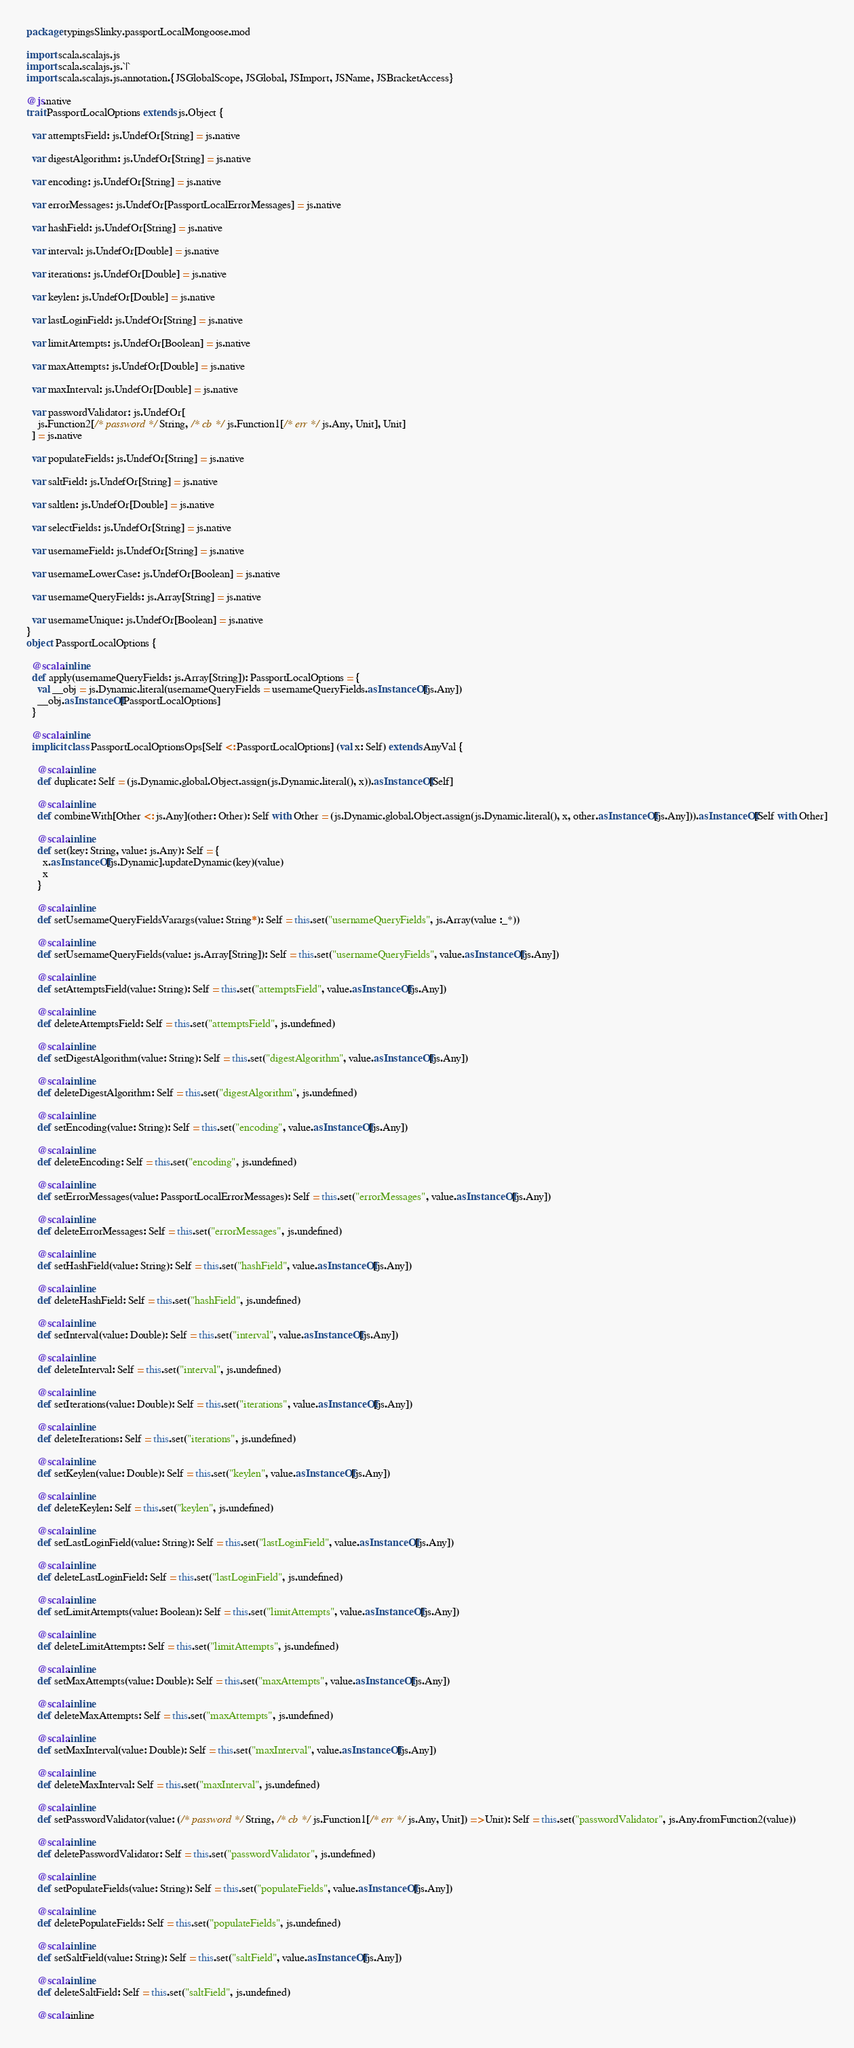Convert code to text. <code><loc_0><loc_0><loc_500><loc_500><_Scala_>package typingsSlinky.passportLocalMongoose.mod

import scala.scalajs.js
import scala.scalajs.js.`|`
import scala.scalajs.js.annotation.{JSGlobalScope, JSGlobal, JSImport, JSName, JSBracketAccess}

@js.native
trait PassportLocalOptions extends js.Object {
  
  var attemptsField: js.UndefOr[String] = js.native
  
  var digestAlgorithm: js.UndefOr[String] = js.native
  
  var encoding: js.UndefOr[String] = js.native
  
  var errorMessages: js.UndefOr[PassportLocalErrorMessages] = js.native
  
  var hashField: js.UndefOr[String] = js.native
  
  var interval: js.UndefOr[Double] = js.native
  
  var iterations: js.UndefOr[Double] = js.native
  
  var keylen: js.UndefOr[Double] = js.native
  
  var lastLoginField: js.UndefOr[String] = js.native
  
  var limitAttempts: js.UndefOr[Boolean] = js.native
  
  var maxAttempts: js.UndefOr[Double] = js.native
  
  var maxInterval: js.UndefOr[Double] = js.native
  
  var passwordValidator: js.UndefOr[
    js.Function2[/* password */ String, /* cb */ js.Function1[/* err */ js.Any, Unit], Unit]
  ] = js.native
  
  var populateFields: js.UndefOr[String] = js.native
  
  var saltField: js.UndefOr[String] = js.native
  
  var saltlen: js.UndefOr[Double] = js.native
  
  var selectFields: js.UndefOr[String] = js.native
  
  var usernameField: js.UndefOr[String] = js.native
  
  var usernameLowerCase: js.UndefOr[Boolean] = js.native
  
  var usernameQueryFields: js.Array[String] = js.native
  
  var usernameUnique: js.UndefOr[Boolean] = js.native
}
object PassportLocalOptions {
  
  @scala.inline
  def apply(usernameQueryFields: js.Array[String]): PassportLocalOptions = {
    val __obj = js.Dynamic.literal(usernameQueryFields = usernameQueryFields.asInstanceOf[js.Any])
    __obj.asInstanceOf[PassportLocalOptions]
  }
  
  @scala.inline
  implicit class PassportLocalOptionsOps[Self <: PassportLocalOptions] (val x: Self) extends AnyVal {
    
    @scala.inline
    def duplicate: Self = (js.Dynamic.global.Object.assign(js.Dynamic.literal(), x)).asInstanceOf[Self]
    
    @scala.inline
    def combineWith[Other <: js.Any](other: Other): Self with Other = (js.Dynamic.global.Object.assign(js.Dynamic.literal(), x, other.asInstanceOf[js.Any])).asInstanceOf[Self with Other]
    
    @scala.inline
    def set(key: String, value: js.Any): Self = {
      x.asInstanceOf[js.Dynamic].updateDynamic(key)(value)
      x
    }
    
    @scala.inline
    def setUsernameQueryFieldsVarargs(value: String*): Self = this.set("usernameQueryFields", js.Array(value :_*))
    
    @scala.inline
    def setUsernameQueryFields(value: js.Array[String]): Self = this.set("usernameQueryFields", value.asInstanceOf[js.Any])
    
    @scala.inline
    def setAttemptsField(value: String): Self = this.set("attemptsField", value.asInstanceOf[js.Any])
    
    @scala.inline
    def deleteAttemptsField: Self = this.set("attemptsField", js.undefined)
    
    @scala.inline
    def setDigestAlgorithm(value: String): Self = this.set("digestAlgorithm", value.asInstanceOf[js.Any])
    
    @scala.inline
    def deleteDigestAlgorithm: Self = this.set("digestAlgorithm", js.undefined)
    
    @scala.inline
    def setEncoding(value: String): Self = this.set("encoding", value.asInstanceOf[js.Any])
    
    @scala.inline
    def deleteEncoding: Self = this.set("encoding", js.undefined)
    
    @scala.inline
    def setErrorMessages(value: PassportLocalErrorMessages): Self = this.set("errorMessages", value.asInstanceOf[js.Any])
    
    @scala.inline
    def deleteErrorMessages: Self = this.set("errorMessages", js.undefined)
    
    @scala.inline
    def setHashField(value: String): Self = this.set("hashField", value.asInstanceOf[js.Any])
    
    @scala.inline
    def deleteHashField: Self = this.set("hashField", js.undefined)
    
    @scala.inline
    def setInterval(value: Double): Self = this.set("interval", value.asInstanceOf[js.Any])
    
    @scala.inline
    def deleteInterval: Self = this.set("interval", js.undefined)
    
    @scala.inline
    def setIterations(value: Double): Self = this.set("iterations", value.asInstanceOf[js.Any])
    
    @scala.inline
    def deleteIterations: Self = this.set("iterations", js.undefined)
    
    @scala.inline
    def setKeylen(value: Double): Self = this.set("keylen", value.asInstanceOf[js.Any])
    
    @scala.inline
    def deleteKeylen: Self = this.set("keylen", js.undefined)
    
    @scala.inline
    def setLastLoginField(value: String): Self = this.set("lastLoginField", value.asInstanceOf[js.Any])
    
    @scala.inline
    def deleteLastLoginField: Self = this.set("lastLoginField", js.undefined)
    
    @scala.inline
    def setLimitAttempts(value: Boolean): Self = this.set("limitAttempts", value.asInstanceOf[js.Any])
    
    @scala.inline
    def deleteLimitAttempts: Self = this.set("limitAttempts", js.undefined)
    
    @scala.inline
    def setMaxAttempts(value: Double): Self = this.set("maxAttempts", value.asInstanceOf[js.Any])
    
    @scala.inline
    def deleteMaxAttempts: Self = this.set("maxAttempts", js.undefined)
    
    @scala.inline
    def setMaxInterval(value: Double): Self = this.set("maxInterval", value.asInstanceOf[js.Any])
    
    @scala.inline
    def deleteMaxInterval: Self = this.set("maxInterval", js.undefined)
    
    @scala.inline
    def setPasswordValidator(value: (/* password */ String, /* cb */ js.Function1[/* err */ js.Any, Unit]) => Unit): Self = this.set("passwordValidator", js.Any.fromFunction2(value))
    
    @scala.inline
    def deletePasswordValidator: Self = this.set("passwordValidator", js.undefined)
    
    @scala.inline
    def setPopulateFields(value: String): Self = this.set("populateFields", value.asInstanceOf[js.Any])
    
    @scala.inline
    def deletePopulateFields: Self = this.set("populateFields", js.undefined)
    
    @scala.inline
    def setSaltField(value: String): Self = this.set("saltField", value.asInstanceOf[js.Any])
    
    @scala.inline
    def deleteSaltField: Self = this.set("saltField", js.undefined)
    
    @scala.inline</code> 